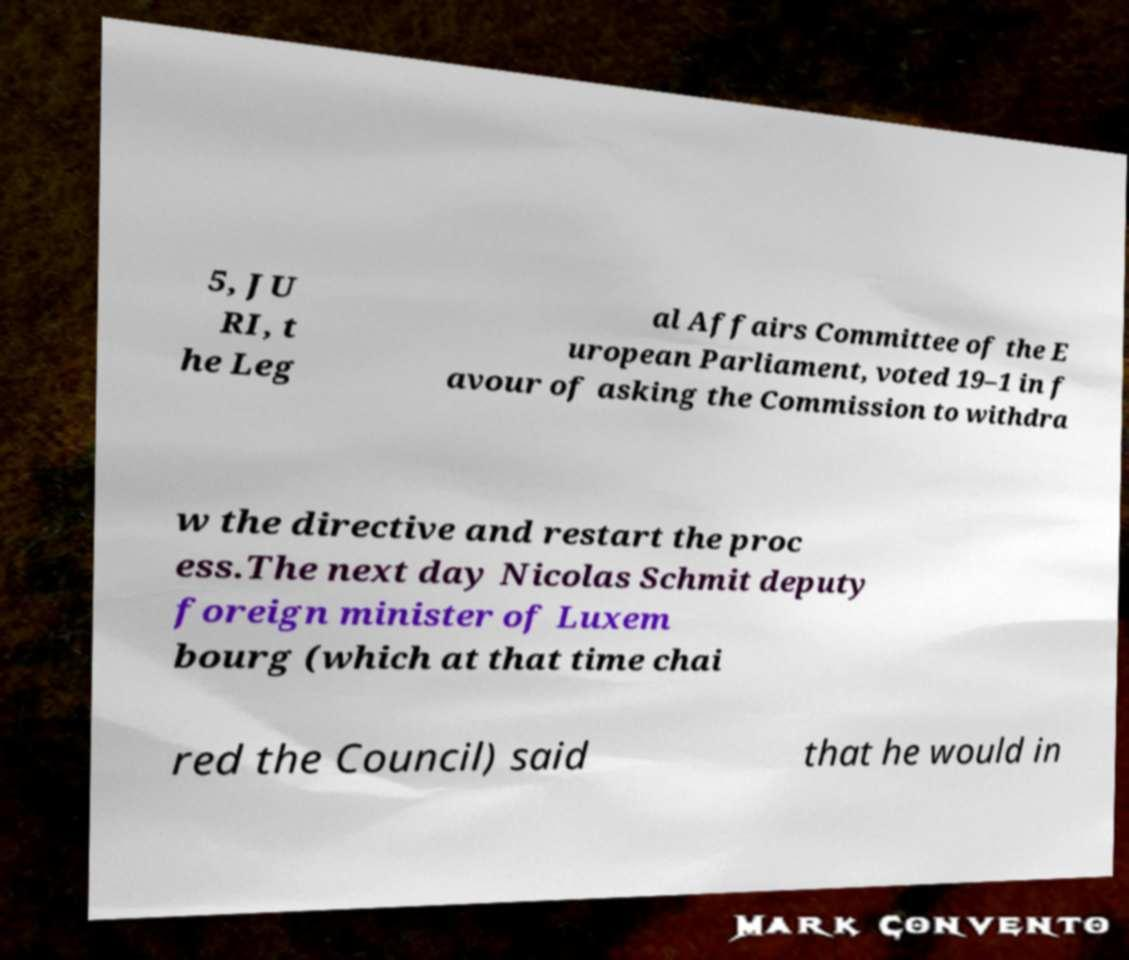Could you assist in decoding the text presented in this image and type it out clearly? 5, JU RI, t he Leg al Affairs Committee of the E uropean Parliament, voted 19–1 in f avour of asking the Commission to withdra w the directive and restart the proc ess.The next day Nicolas Schmit deputy foreign minister of Luxem bourg (which at that time chai red the Council) said that he would in 